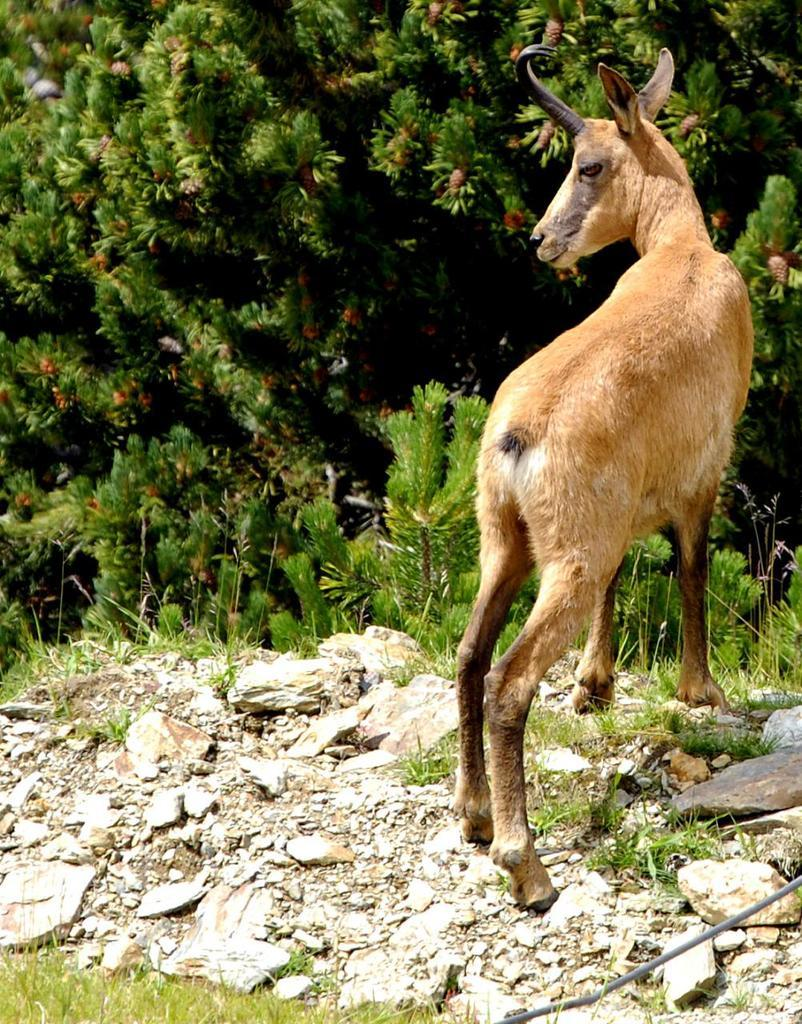What type of creature is in the image? There is an animal in the image. Where is the animal located? The animal is on the ground. What type of vegetation can be seen in the image? There are trees and grass in the image. What type of polish is the animal using to shine its fur in the image? There is no polish or indication of grooming in the image; the animal is simply on the ground. 